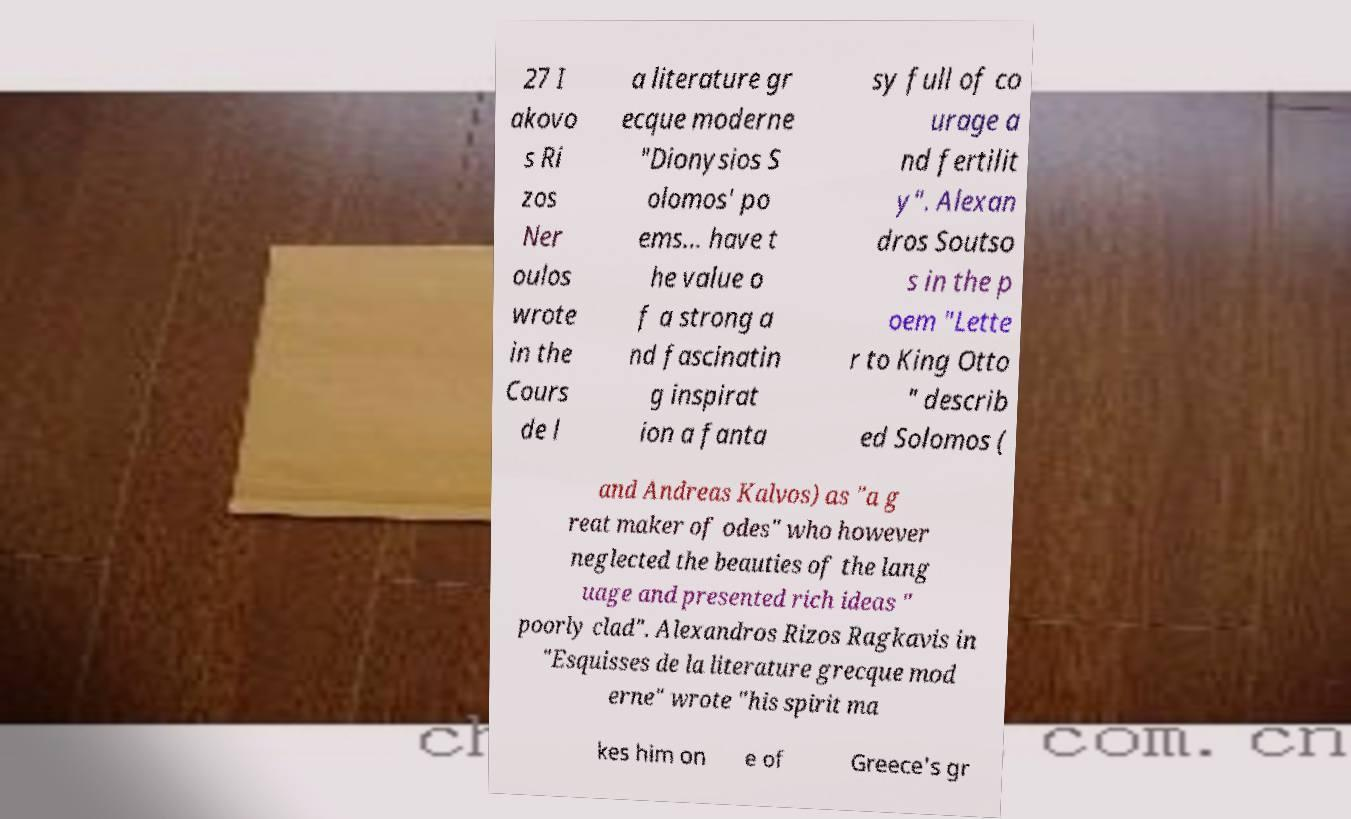Could you extract and type out the text from this image? 27 I akovo s Ri zos Ner oulos wrote in the Cours de l a literature gr ecque moderne "Dionysios S olomos' po ems... have t he value o f a strong a nd fascinatin g inspirat ion a fanta sy full of co urage a nd fertilit y". Alexan dros Soutso s in the p oem "Lette r to King Otto " describ ed Solomos ( and Andreas Kalvos) as "a g reat maker of odes" who however neglected the beauties of the lang uage and presented rich ideas " poorly clad". Alexandros Rizos Ragkavis in "Esquisses de la literature grecque mod erne" wrote "his spirit ma kes him on e of Greece's gr 